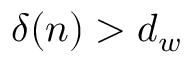Convert formula to latex. <formula><loc_0><loc_0><loc_500><loc_500>\delta ( n ) > d _ { w }</formula> 